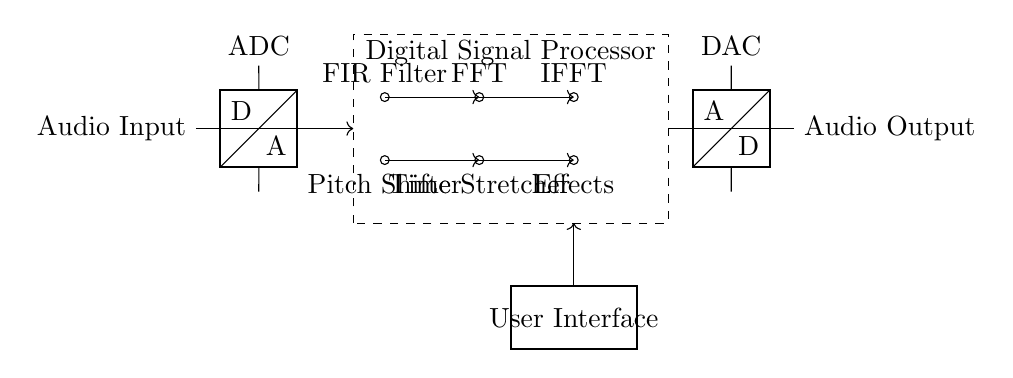What is the primary function of the module labeled "ADC"? The ADC, or Analog-to-Digital Converter, converts the incoming audio signal from analog to digital format, which is necessary for processing in the digital domain.
Answer: Analog-to-Digital Converter What is the output after the DSP block? The output after the DSP block is the modified audio signal, which is still in digital form before it reaches the DAC for conversion back to analog.
Answer: Modified audio signal How many main processing components are there within the DSP block? There are five main processing components, including the FIR Filter, FFT, IFFT, Pitch Shifter, and Time Stretcher, all of which are used to manipulate the audio signal.
Answer: Five What is the role of the "DAC" in this circuit? The DAC, or Digital-to-Analog Converter, takes the processed digital signal from the DSP and converts it back into an analog signal suitable for playback through speakers or headphones.
Answer: Digital-to-Analog Converter What type of signal processing is this circuit designed for? This circuit is specifically designed for digital signal processing of audio effects and voice modulation, allowing real-time manipulation of audio signals.
Answer: Audio effects and voice modulation Which component directly interfaces with the user? The User Interface component directly interfaces with the user, enabling control over the variables and settings of the audio effects being processed.
Answer: User Interface 